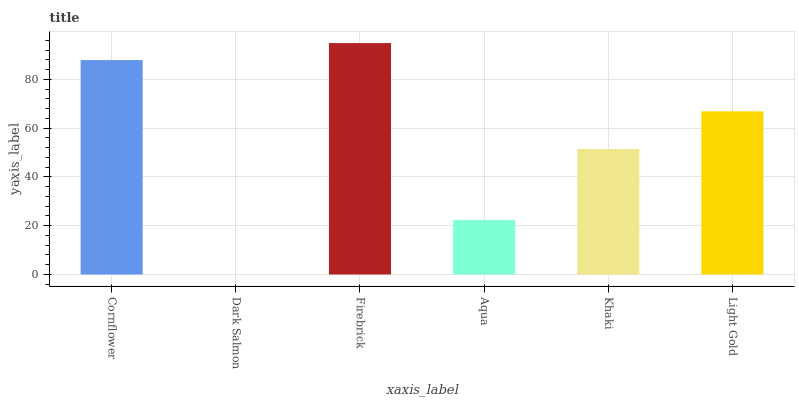Is Firebrick the minimum?
Answer yes or no. No. Is Dark Salmon the maximum?
Answer yes or no. No. Is Firebrick greater than Dark Salmon?
Answer yes or no. Yes. Is Dark Salmon less than Firebrick?
Answer yes or no. Yes. Is Dark Salmon greater than Firebrick?
Answer yes or no. No. Is Firebrick less than Dark Salmon?
Answer yes or no. No. Is Light Gold the high median?
Answer yes or no. Yes. Is Khaki the low median?
Answer yes or no. Yes. Is Firebrick the high median?
Answer yes or no. No. Is Light Gold the low median?
Answer yes or no. No. 